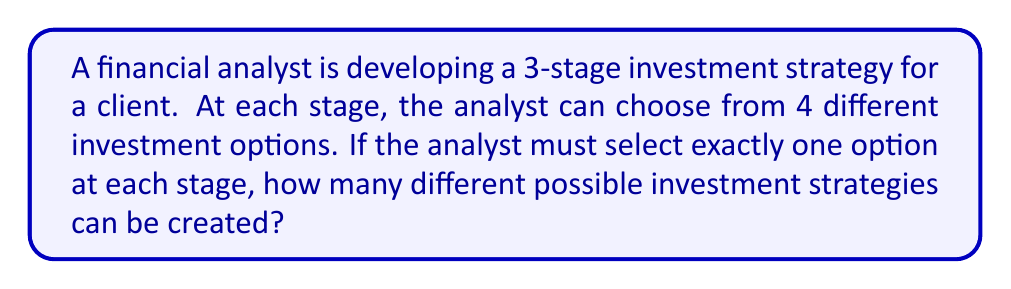Could you help me with this problem? Let's approach this step-by-step:

1) We have a multi-stage decision-making process with 3 stages.

2) At each stage, there are 4 options to choose from.

3) We need to make a choice at every stage, and the choices are independent of each other.

4) This scenario can be modeled using the multiplication principle of counting.

5) The multiplication principle states that if we have $n$ independent events, and each event $i$ has $k_i$ possible outcomes, then the total number of possible outcomes for all events is the product $k_1 \times k_2 \times ... \times k_n$.

6) In our case:
   - We have 3 independent events (the 3 stages)
   - Each event has 4 possible outcomes (the 4 investment options)

7) Therefore, the total number of possible outcomes is:

   $$ 4 \times 4 \times 4 = 4^3 = 64 $$

Thus, the financial analyst can create 64 different investment strategies.
Answer: 64 